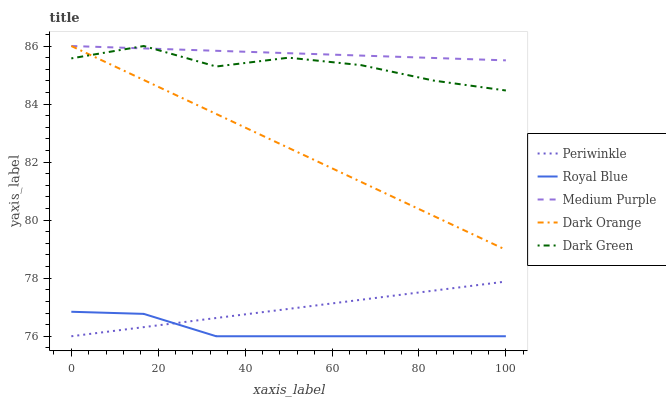Does Royal Blue have the minimum area under the curve?
Answer yes or no. Yes. Does Medium Purple have the maximum area under the curve?
Answer yes or no. Yes. Does Dark Green have the minimum area under the curve?
Answer yes or no. No. Does Dark Green have the maximum area under the curve?
Answer yes or no. No. Is Medium Purple the smoothest?
Answer yes or no. Yes. Is Dark Green the roughest?
Answer yes or no. Yes. Is Royal Blue the smoothest?
Answer yes or no. No. Is Royal Blue the roughest?
Answer yes or no. No. Does Dark Green have the lowest value?
Answer yes or no. No. Does Royal Blue have the highest value?
Answer yes or no. No. Is Royal Blue less than Dark Orange?
Answer yes or no. Yes. Is Dark Green greater than Periwinkle?
Answer yes or no. Yes. Does Royal Blue intersect Dark Orange?
Answer yes or no. No. 